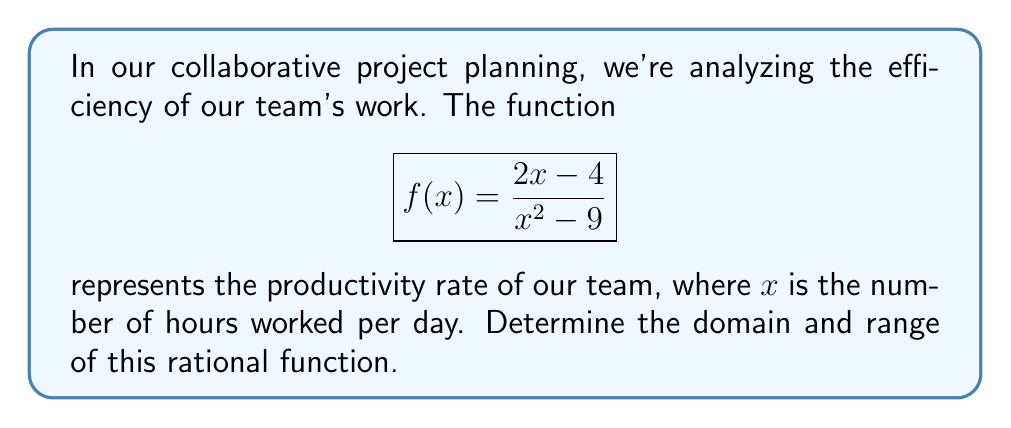Can you answer this question? Let's approach this step-by-step:

1) Domain:
   The domain of a rational function includes all real numbers except those that make the denominator zero.
   
   Set the denominator equal to zero and solve:
   $$x^2-9 = 0$$
   $$(x+3)(x-3) = 0$$
   $$x = -3 \text{ or } x = 3$$

   Therefore, the domain is all real numbers except -3 and 3.

2) Range:
   To find the range, let's analyze the behavior of the function:

   a) As $x$ approaches infinity or negative infinity, the function approaches 0:
      $$\lim_{x \to \pm\infty} \frac{2x-4}{x^2-9} = 0$$

   b) Let's find the vertical asymptotes:
      When $x = 3$ or $x = -3$, the function approaches positive or negative infinity.

   c) To find any horizontal asymptote, divide the highest degree terms:
      $$\frac{2x}{x^2} = \frac{2}{x}$$
      As $x$ approaches infinity, this approaches 0.

   d) To find any potential extrema, let's differentiate and set to zero:
      $$f'(x) = \frac{2(x^2-9) - (2x-4)(2x)}{(x^2-9)^2} = \frac{-2x^2+36+8x-16}{(x^2-9)^2} = \frac{-2(x-1)(x-9)}{(x^2-9)^2}$$
      
      Setting this to zero (ignoring the denominator as it's never zero where $f(x)$ is defined):
      $$-2(x-1)(x-9) = 0$$
      $$x = 1 \text{ or } x = 9$$

      $f(1) = -\frac{2}{4} = -\frac{1}{2}$
      $f(9) = \frac{14}{72} = \frac{7}{36}$

Therefore, the range of $f(x)$ is all real numbers except the open interval $(-\frac{1}{2}, \frac{7}{36})$.
Answer: Domain: $\{x \in \mathbb{R} : x \neq -3 \text{ and } x \neq 3\}$
Range: $(-\infty, -\frac{1}{2}) \cup (\frac{7}{36}, \infty)$ 